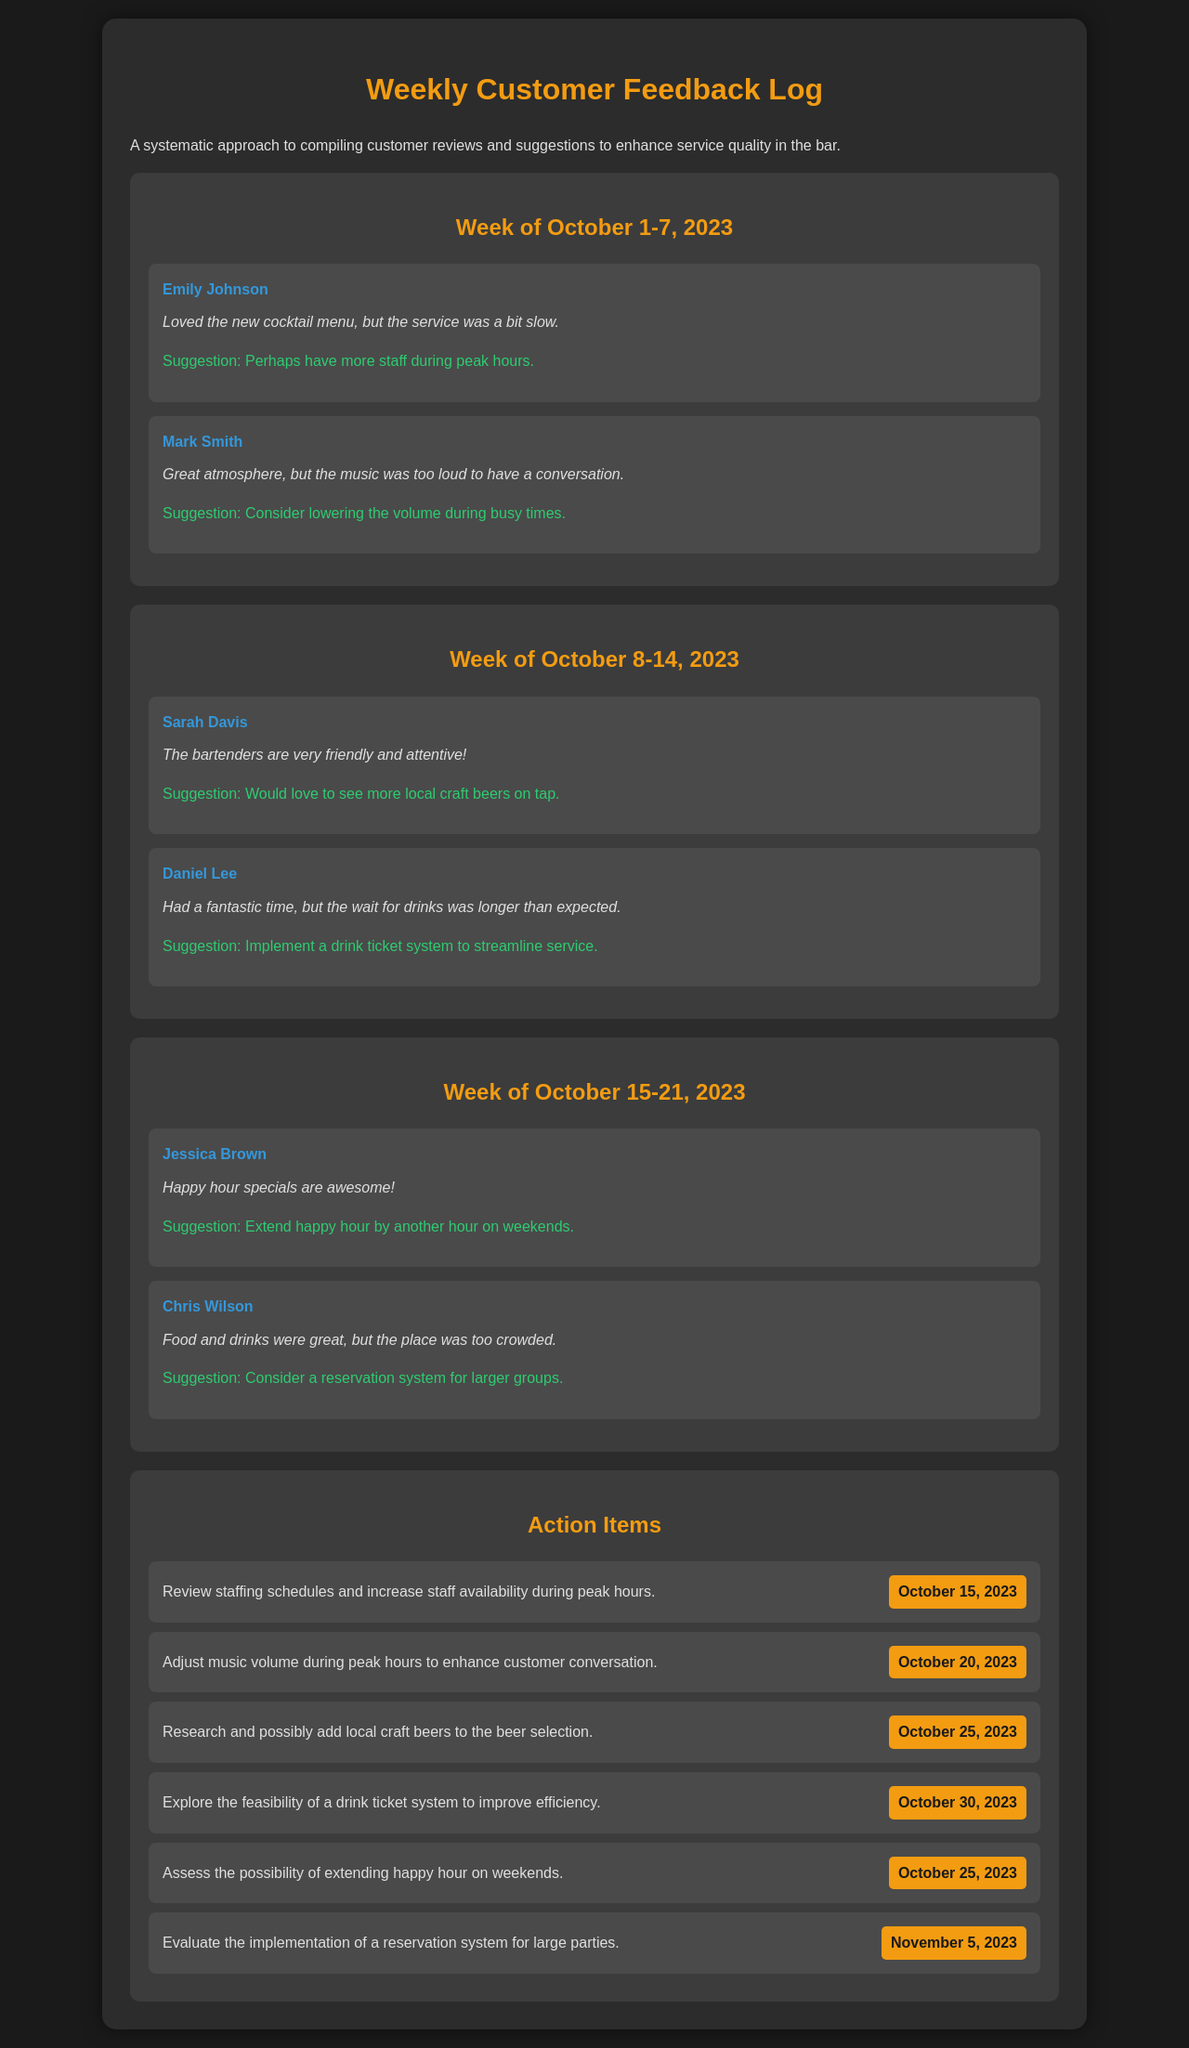What is the week covered in the first feedback section? The first feedback section covers the week from October 1 to October 7, 2023.
Answer: October 1-7, 2023 Who provided a suggestion about the music volume? Mark Smith suggested considering lowering the music volume during busy times.
Answer: Mark Smith What was Jessica Brown's feedback about happy hour? Jessica Brown mentioned that the happy hour specials are awesome.
Answer: Awesome What is the deadline for reviewing staffing schedules? The deadline for reviewing staffing schedules is October 15, 2023.
Answer: October 15, 2023 Which suggestion relates to local craft beers? Sarah Davis suggested seeing more local craft beers on tap.
Answer: More local craft beers What is the primary purpose of this document? The primary purpose of this document is to compile customer reviews and suggestions to enhance service quality.
Answer: Enhance service quality How many action items are listed in the document? According to the action items section, there are six action items listed.
Answer: Six What was Daniel Lee's concern regarding drink service? Daniel Lee's concern was that the wait for drinks was longer than expected.
Answer: Longer than expected Which suggestion was made regarding large groups? Chris Wilson suggested considering a reservation system for larger groups.
Answer: Reservation system 